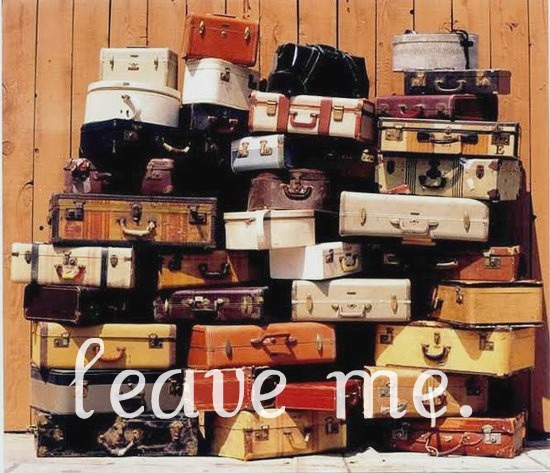Identify and read out the text in this image. leave me 